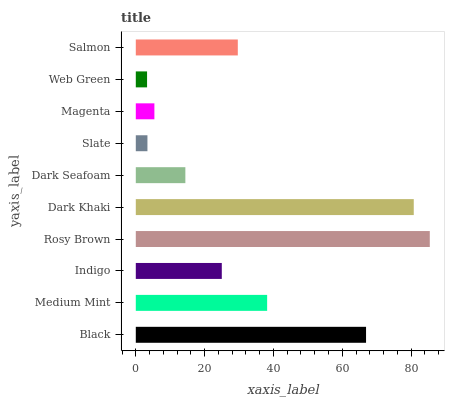Is Web Green the minimum?
Answer yes or no. Yes. Is Rosy Brown the maximum?
Answer yes or no. Yes. Is Medium Mint the minimum?
Answer yes or no. No. Is Medium Mint the maximum?
Answer yes or no. No. Is Black greater than Medium Mint?
Answer yes or no. Yes. Is Medium Mint less than Black?
Answer yes or no. Yes. Is Medium Mint greater than Black?
Answer yes or no. No. Is Black less than Medium Mint?
Answer yes or no. No. Is Salmon the high median?
Answer yes or no. Yes. Is Indigo the low median?
Answer yes or no. Yes. Is Black the high median?
Answer yes or no. No. Is Rosy Brown the low median?
Answer yes or no. No. 